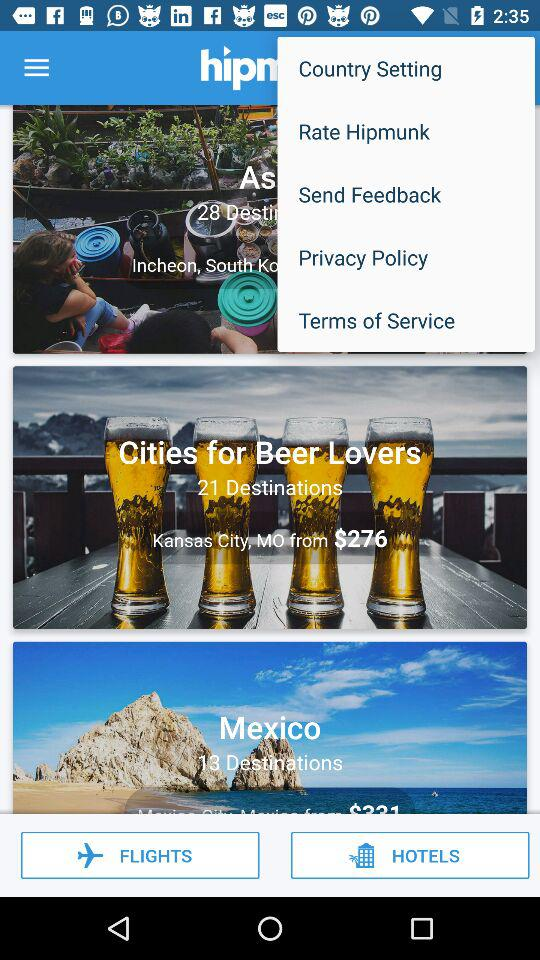What is the currency for the price? The currency for the price is in dollars. 